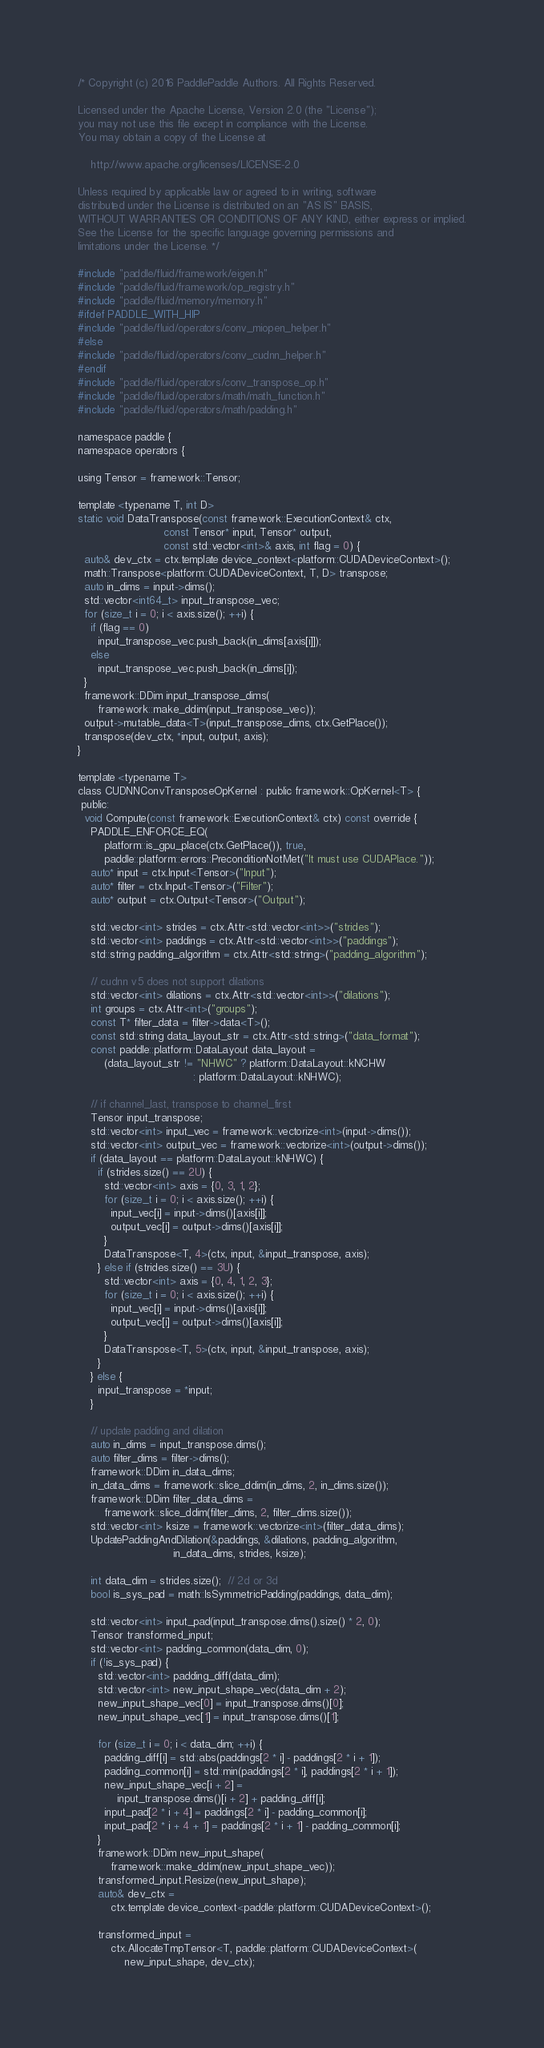<code> <loc_0><loc_0><loc_500><loc_500><_Cuda_>/* Copyright (c) 2016 PaddlePaddle Authors. All Rights Reserved.

Licensed under the Apache License, Version 2.0 (the "License");
you may not use this file except in compliance with the License.
You may obtain a copy of the License at

    http://www.apache.org/licenses/LICENSE-2.0

Unless required by applicable law or agreed to in writing, software
distributed under the License is distributed on an "AS IS" BASIS,
WITHOUT WARRANTIES OR CONDITIONS OF ANY KIND, either express or implied.
See the License for the specific language governing permissions and
limitations under the License. */

#include "paddle/fluid/framework/eigen.h"
#include "paddle/fluid/framework/op_registry.h"
#include "paddle/fluid/memory/memory.h"
#ifdef PADDLE_WITH_HIP
#include "paddle/fluid/operators/conv_miopen_helper.h"
#else
#include "paddle/fluid/operators/conv_cudnn_helper.h"
#endif
#include "paddle/fluid/operators/conv_transpose_op.h"
#include "paddle/fluid/operators/math/math_function.h"
#include "paddle/fluid/operators/math/padding.h"

namespace paddle {
namespace operators {

using Tensor = framework::Tensor;

template <typename T, int D>
static void DataTranspose(const framework::ExecutionContext& ctx,
                          const Tensor* input, Tensor* output,
                          const std::vector<int>& axis, int flag = 0) {
  auto& dev_ctx = ctx.template device_context<platform::CUDADeviceContext>();
  math::Transpose<platform::CUDADeviceContext, T, D> transpose;
  auto in_dims = input->dims();
  std::vector<int64_t> input_transpose_vec;
  for (size_t i = 0; i < axis.size(); ++i) {
    if (flag == 0)
      input_transpose_vec.push_back(in_dims[axis[i]]);
    else
      input_transpose_vec.push_back(in_dims[i]);
  }
  framework::DDim input_transpose_dims(
      framework::make_ddim(input_transpose_vec));
  output->mutable_data<T>(input_transpose_dims, ctx.GetPlace());
  transpose(dev_ctx, *input, output, axis);
}

template <typename T>
class CUDNNConvTransposeOpKernel : public framework::OpKernel<T> {
 public:
  void Compute(const framework::ExecutionContext& ctx) const override {
    PADDLE_ENFORCE_EQ(
        platform::is_gpu_place(ctx.GetPlace()), true,
        paddle::platform::errors::PreconditionNotMet("It must use CUDAPlace."));
    auto* input = ctx.Input<Tensor>("Input");
    auto* filter = ctx.Input<Tensor>("Filter");
    auto* output = ctx.Output<Tensor>("Output");

    std::vector<int> strides = ctx.Attr<std::vector<int>>("strides");
    std::vector<int> paddings = ctx.Attr<std::vector<int>>("paddings");
    std::string padding_algorithm = ctx.Attr<std::string>("padding_algorithm");

    // cudnn v5 does not support dilations
    std::vector<int> dilations = ctx.Attr<std::vector<int>>("dilations");
    int groups = ctx.Attr<int>("groups");
    const T* filter_data = filter->data<T>();
    const std::string data_layout_str = ctx.Attr<std::string>("data_format");
    const paddle::platform::DataLayout data_layout =
        (data_layout_str != "NHWC" ? platform::DataLayout::kNCHW
                                   : platform::DataLayout::kNHWC);

    // if channel_last, transpose to channel_first
    Tensor input_transpose;
    std::vector<int> input_vec = framework::vectorize<int>(input->dims());
    std::vector<int> output_vec = framework::vectorize<int>(output->dims());
    if (data_layout == platform::DataLayout::kNHWC) {
      if (strides.size() == 2U) {
        std::vector<int> axis = {0, 3, 1, 2};
        for (size_t i = 0; i < axis.size(); ++i) {
          input_vec[i] = input->dims()[axis[i]];
          output_vec[i] = output->dims()[axis[i]];
        }
        DataTranspose<T, 4>(ctx, input, &input_transpose, axis);
      } else if (strides.size() == 3U) {
        std::vector<int> axis = {0, 4, 1, 2, 3};
        for (size_t i = 0; i < axis.size(); ++i) {
          input_vec[i] = input->dims()[axis[i]];
          output_vec[i] = output->dims()[axis[i]];
        }
        DataTranspose<T, 5>(ctx, input, &input_transpose, axis);
      }
    } else {
      input_transpose = *input;
    }

    // update padding and dilation
    auto in_dims = input_transpose.dims();
    auto filter_dims = filter->dims();
    framework::DDim in_data_dims;
    in_data_dims = framework::slice_ddim(in_dims, 2, in_dims.size());
    framework::DDim filter_data_dims =
        framework::slice_ddim(filter_dims, 2, filter_dims.size());
    std::vector<int> ksize = framework::vectorize<int>(filter_data_dims);
    UpdatePaddingAndDilation(&paddings, &dilations, padding_algorithm,
                             in_data_dims, strides, ksize);

    int data_dim = strides.size();  // 2d or 3d
    bool is_sys_pad = math::IsSymmetricPadding(paddings, data_dim);

    std::vector<int> input_pad(input_transpose.dims().size() * 2, 0);
    Tensor transformed_input;
    std::vector<int> padding_common(data_dim, 0);
    if (!is_sys_pad) {
      std::vector<int> padding_diff(data_dim);
      std::vector<int> new_input_shape_vec(data_dim + 2);
      new_input_shape_vec[0] = input_transpose.dims()[0];
      new_input_shape_vec[1] = input_transpose.dims()[1];

      for (size_t i = 0; i < data_dim; ++i) {
        padding_diff[i] = std::abs(paddings[2 * i] - paddings[2 * i + 1]);
        padding_common[i] = std::min(paddings[2 * i], paddings[2 * i + 1]);
        new_input_shape_vec[i + 2] =
            input_transpose.dims()[i + 2] + padding_diff[i];
        input_pad[2 * i + 4] = paddings[2 * i] - padding_common[i];
        input_pad[2 * i + 4 + 1] = paddings[2 * i + 1] - padding_common[i];
      }
      framework::DDim new_input_shape(
          framework::make_ddim(new_input_shape_vec));
      transformed_input.Resize(new_input_shape);
      auto& dev_ctx =
          ctx.template device_context<paddle::platform::CUDADeviceContext>();

      transformed_input =
          ctx.AllocateTmpTensor<T, paddle::platform::CUDADeviceContext>(
              new_input_shape, dev_ctx);</code> 